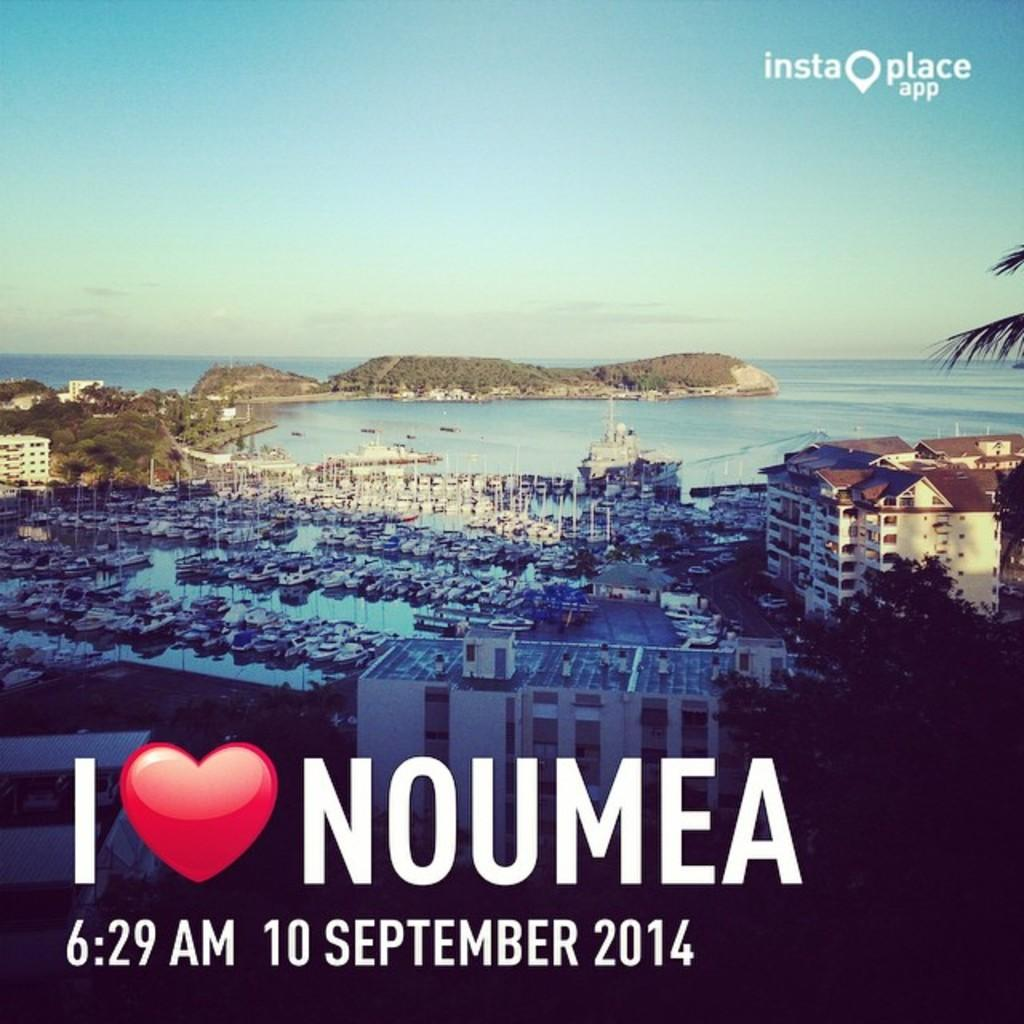<image>
Write a terse but informative summary of the picture. a city image with an I love Noumea phrase on it 